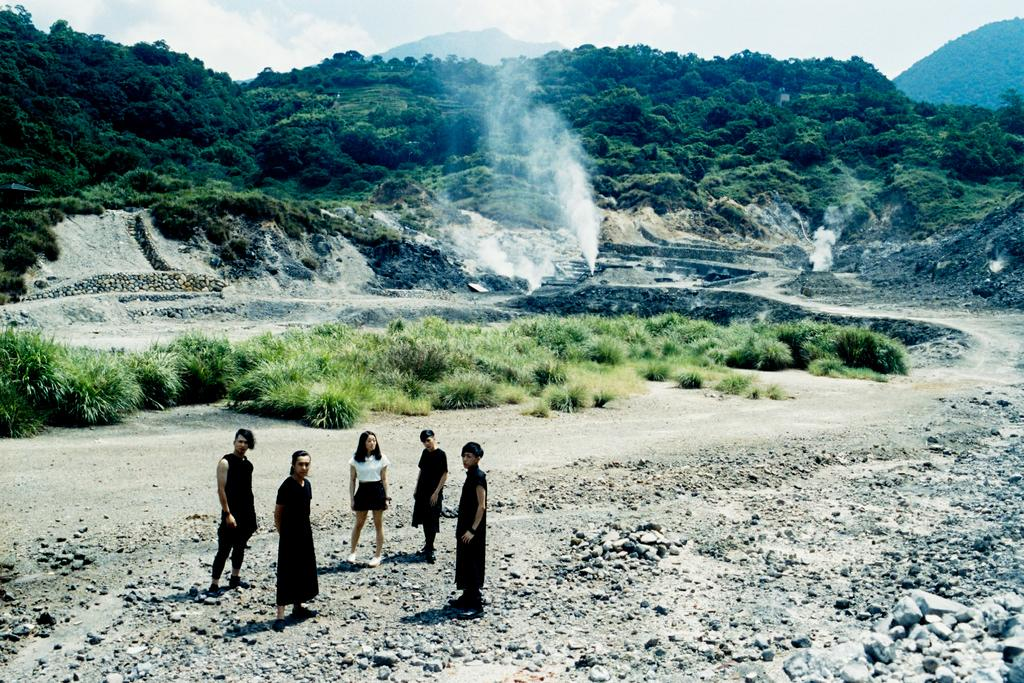What is happening in the center of the image? There are persons standing in the center of the image. What can be seen in the background of the image? There are plants, trees, and mountains in the background of the image. How would you describe the sky in the image? The sky is cloudy in the image. What type of texture can be seen on the trees in the image? There is no specific texture mentioned or visible on the trees in the image; we can only see their general shape and color. 